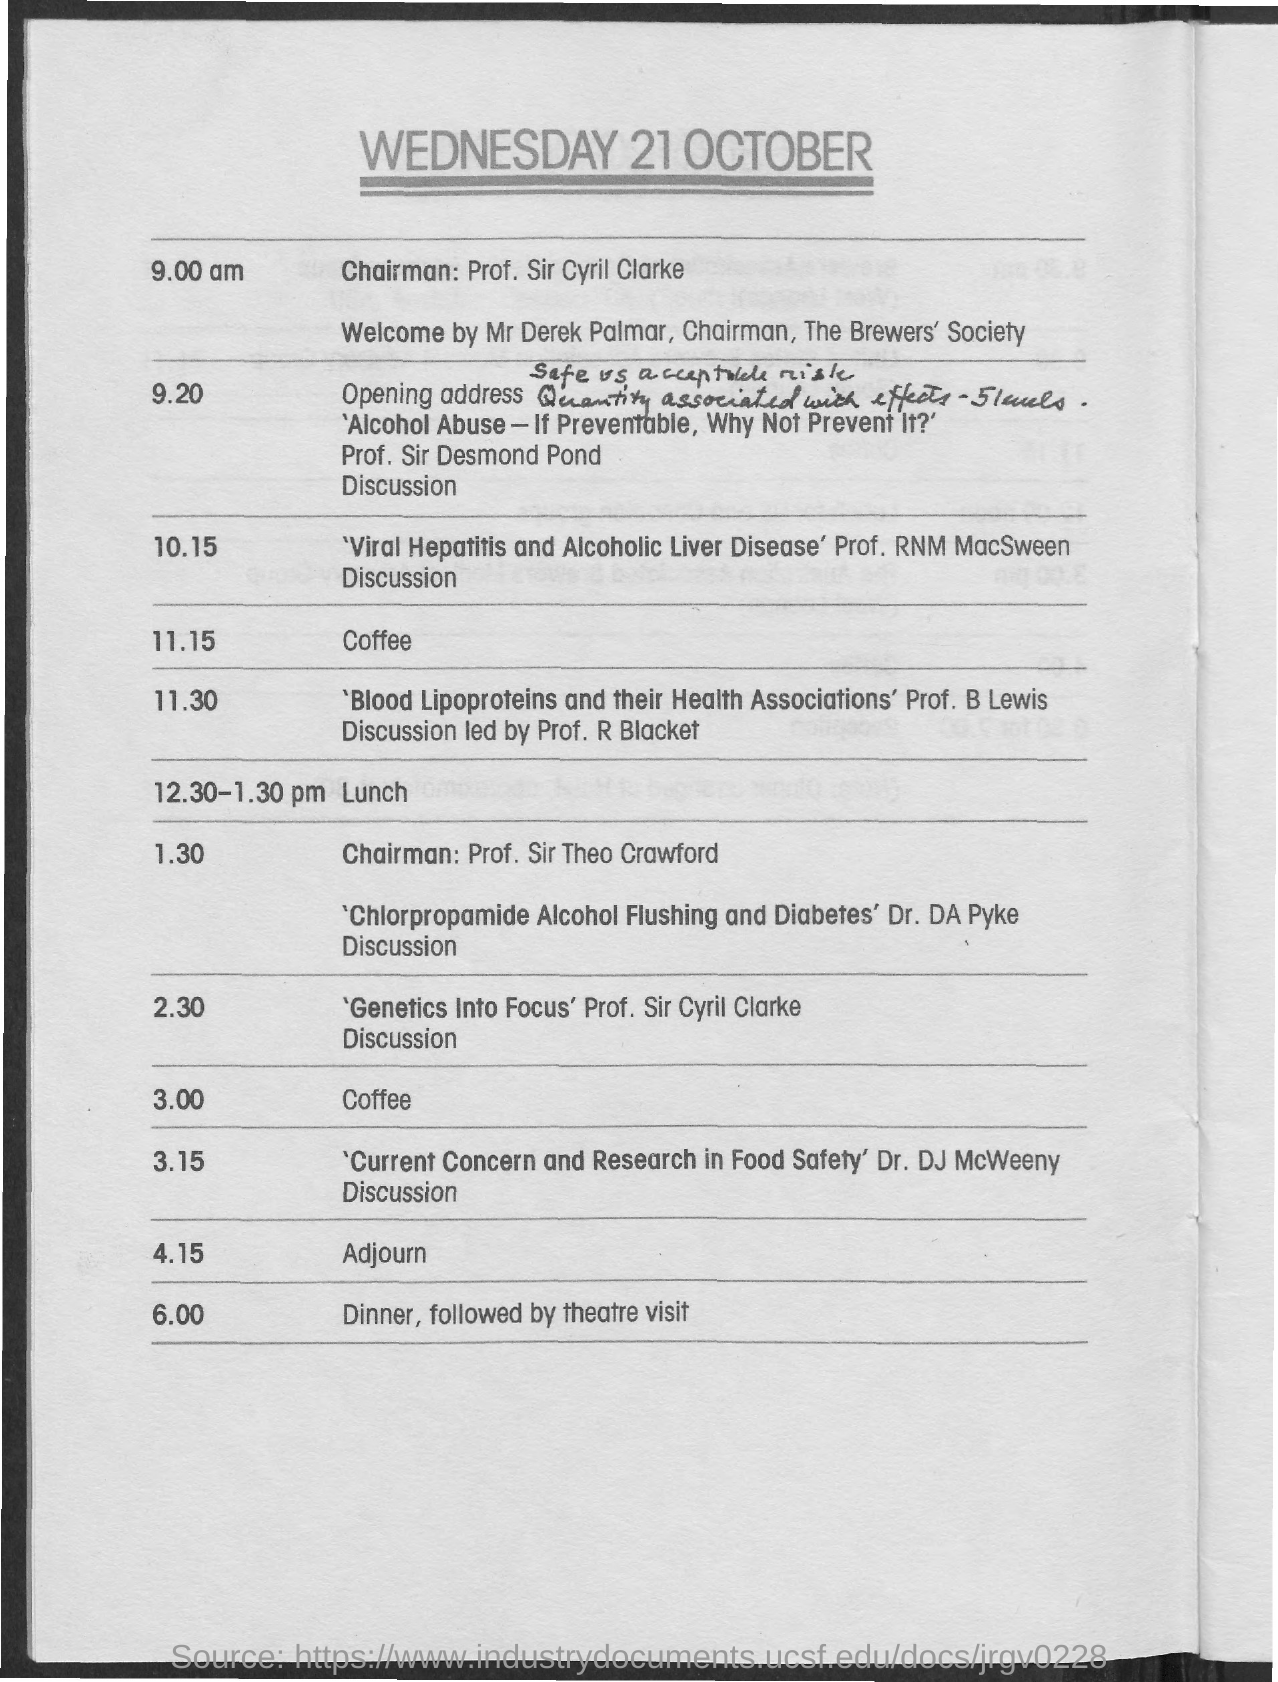When is the meeting adjorned?
Provide a succinct answer. 4.15. Who is giving welcome speech?
Ensure brevity in your answer.  Mr. Derek Palmar. What is the time scheduled for lunch?
Your response must be concise. 12.30-1.30 pm. Who is discussing about genetics into focus?
Offer a very short reply. Prof. Sir Cyril Clarke. Dicussion on Chlorpropamide Alcohol Flushing and Diabetes is given by?
Offer a terse response. Dr. DA Pyke. Discussion on Viral Hepatitis and Alcoholic Liver Disease is given by?
Offer a very short reply. Prof. RNM MacSween. 